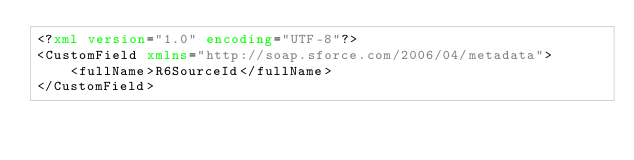<code> <loc_0><loc_0><loc_500><loc_500><_XML_><?xml version="1.0" encoding="UTF-8"?>
<CustomField xmlns="http://soap.sforce.com/2006/04/metadata">
    <fullName>R6SourceId</fullName>
</CustomField>
</code> 